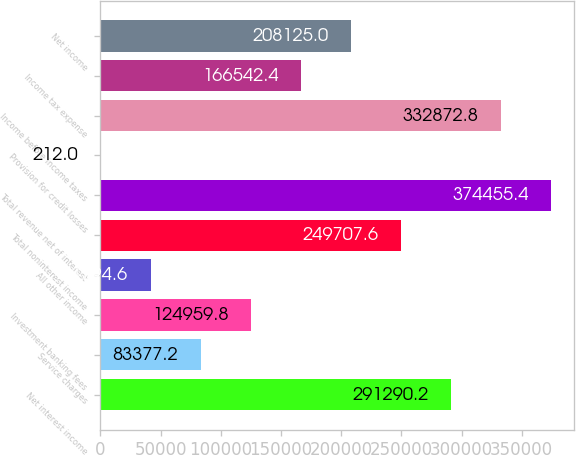Convert chart to OTSL. <chart><loc_0><loc_0><loc_500><loc_500><bar_chart><fcel>Net interest income<fcel>Service charges<fcel>Investment banking fees<fcel>All other income<fcel>Total noninterest income<fcel>Total revenue net of interest<fcel>Provision for credit losses<fcel>Income before income taxes<fcel>Income tax expense<fcel>Net income<nl><fcel>291290<fcel>83377.2<fcel>124960<fcel>41794.6<fcel>249708<fcel>374455<fcel>212<fcel>332873<fcel>166542<fcel>208125<nl></chart> 